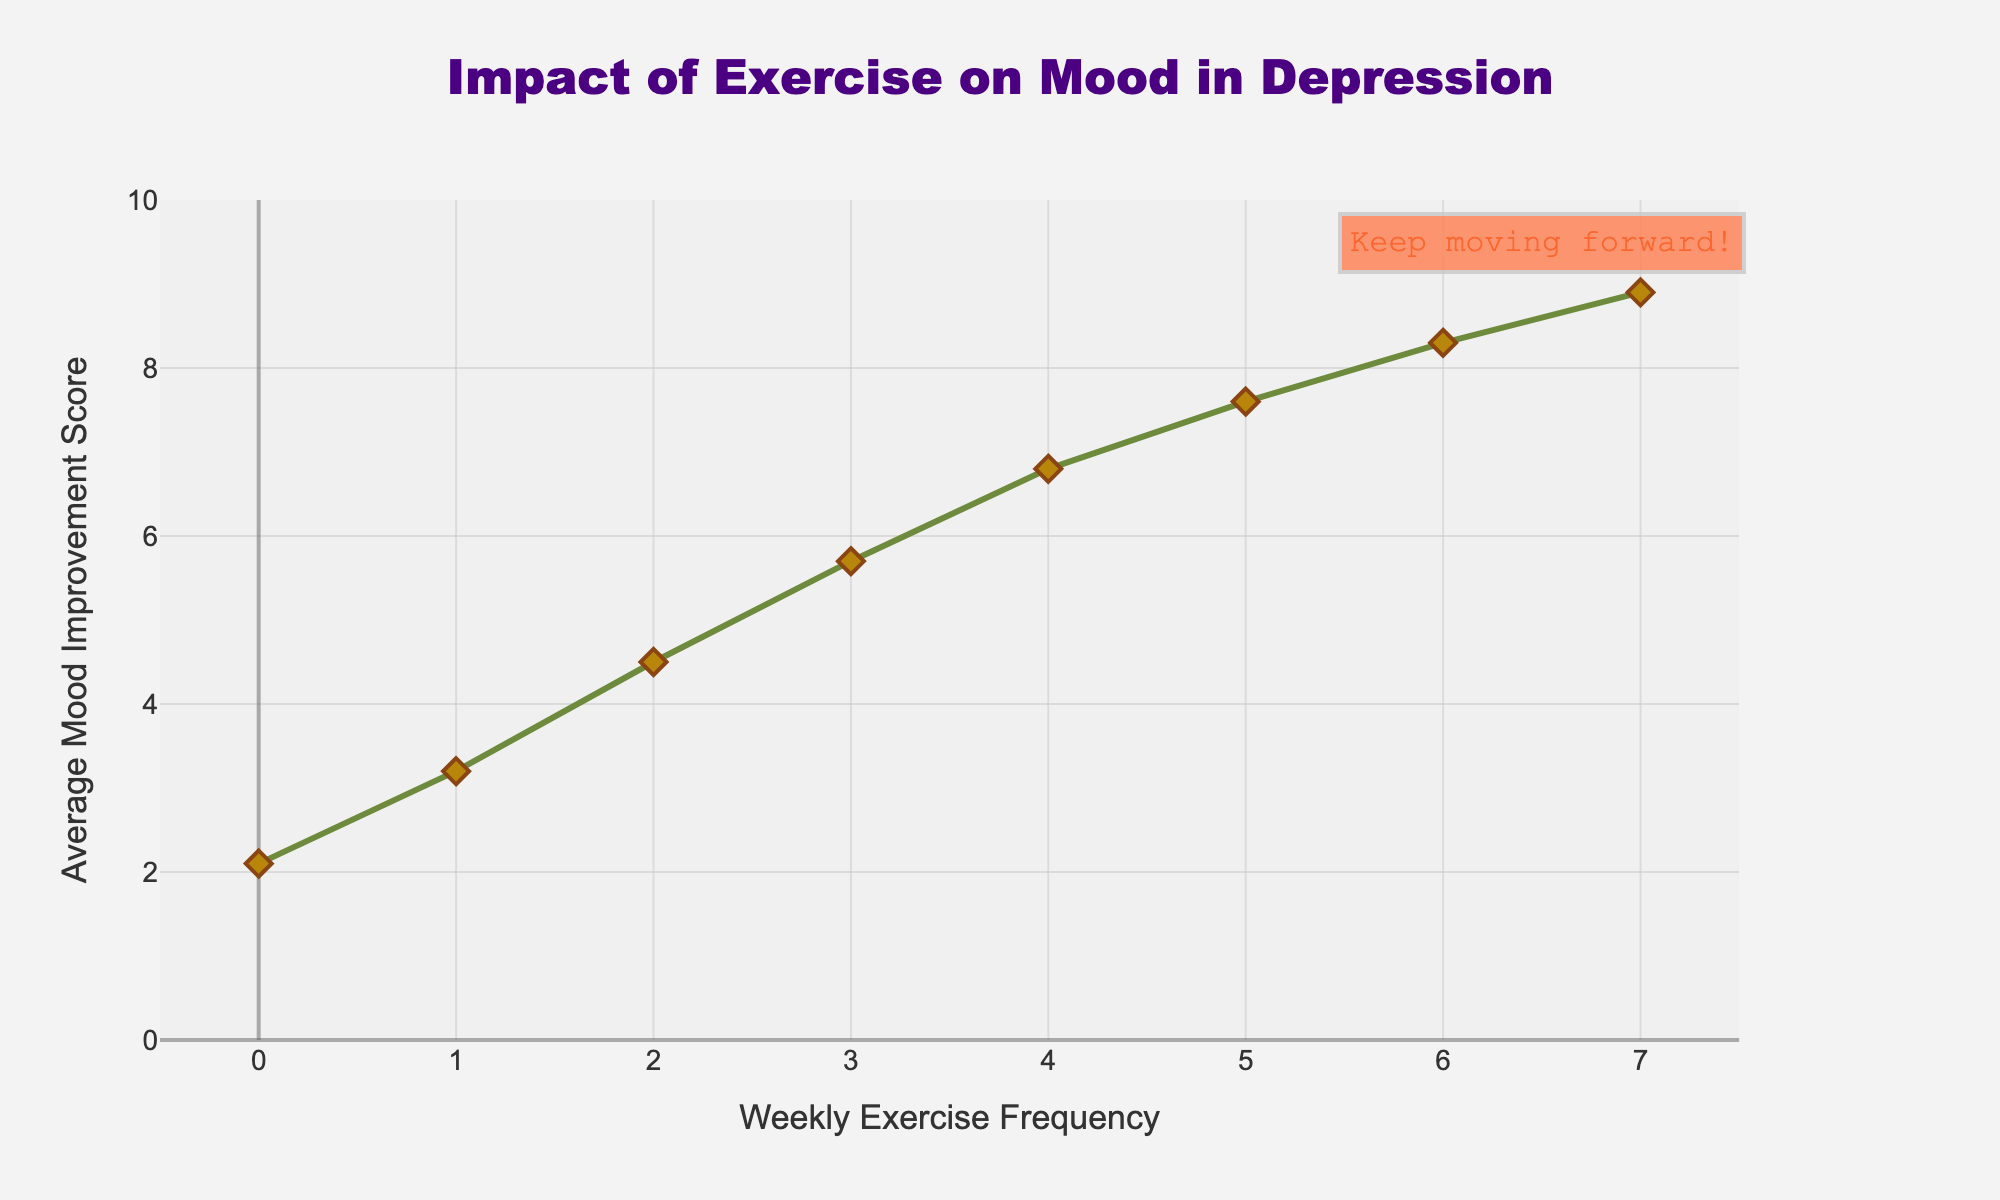What is the Weekly Exercise Frequency with the lowest Average Mood Improvement Score? The graph shows that the lowest Average Mood Improvement Score occurs at a Weekly Exercise Frequency of 0.
Answer: 0 How much does the Average Mood Improvement Score increase when the Weekly Exercise Frequency changes from 1 to 3? The Average Mood Improvement Score at a Weekly Exercise Frequency of 1 is 3.2, and at 3, it is 5.7. The increase is 5.7 - 3.2 = 2.5.
Answer: 2.5 What is the difference in the Average Mood Improvement Score between Weekly Exercise Frequencies of 2 and 4? The Average Mood Improvement Score at a Weekly Exercise Frequency of 2 is 4.5, and at 4, it is 6.8. The difference is 6.8 - 4.5 = 2.3.
Answer: 2.3 At which Weekly Exercise Frequency does the Average Mood Improvement Score first exceed 7? The graph shows that the Average Mood Improvement Score first exceeds 7 at a Weekly Exercise Frequency of 5.
Answer: 5 Which Weekly Exercise Frequency corresponds to the highest Average Mood Improvement Score, and what is the score? The highest Average Mood Improvement Score is 8.9, which corresponds to a Weekly Exercise Frequency of 7.
Answer: 7, 8.9 By how much does the Average Mood Improvement Score change on average per unit increase in Weekly Exercise Frequency from 0 to 7? To find the average change, take the difference in scores at the highest and lowest frequencies and divide by the number of intervals: (8.9 - 2.1) / 7 = 6.8 / 7 ≈ 0.97.
Answer: 0.97 What visual element indicates the trend of mood improvement and what are its attributes? The mood improvement trend is visualized by a line with markers. The line is green, and the markers are diamond-shaped and golden with brown edges.
Answer: Line with diamond-shaped markers, green line, golden markers with brown edges Is the mood improvement trend linear or non-linear based on the plot? The plot shows a steady increase in the Average Mood Improvement Score with increasing Weekly Exercise Frequency, suggesting a linear trend.
Answer: Linear What text annotation is included in the plot to provide motivation and where is it placed? The annotation "Keep moving forward!" is included near the top of the plot at a Weekly Exercise Frequency of around 6.5 and a mood score of 9.5.
Answer: "Keep moving forward!" near 6.5, 9.5 How does the Average Mood Improvement Score change between exercise frequencies of 3 and 5? The score at a frequency of 3 is 5.7, and at a frequency of 5, it is 7.6. The change is 7.6 - 5.7 = 1.9.
Answer: 1.9 